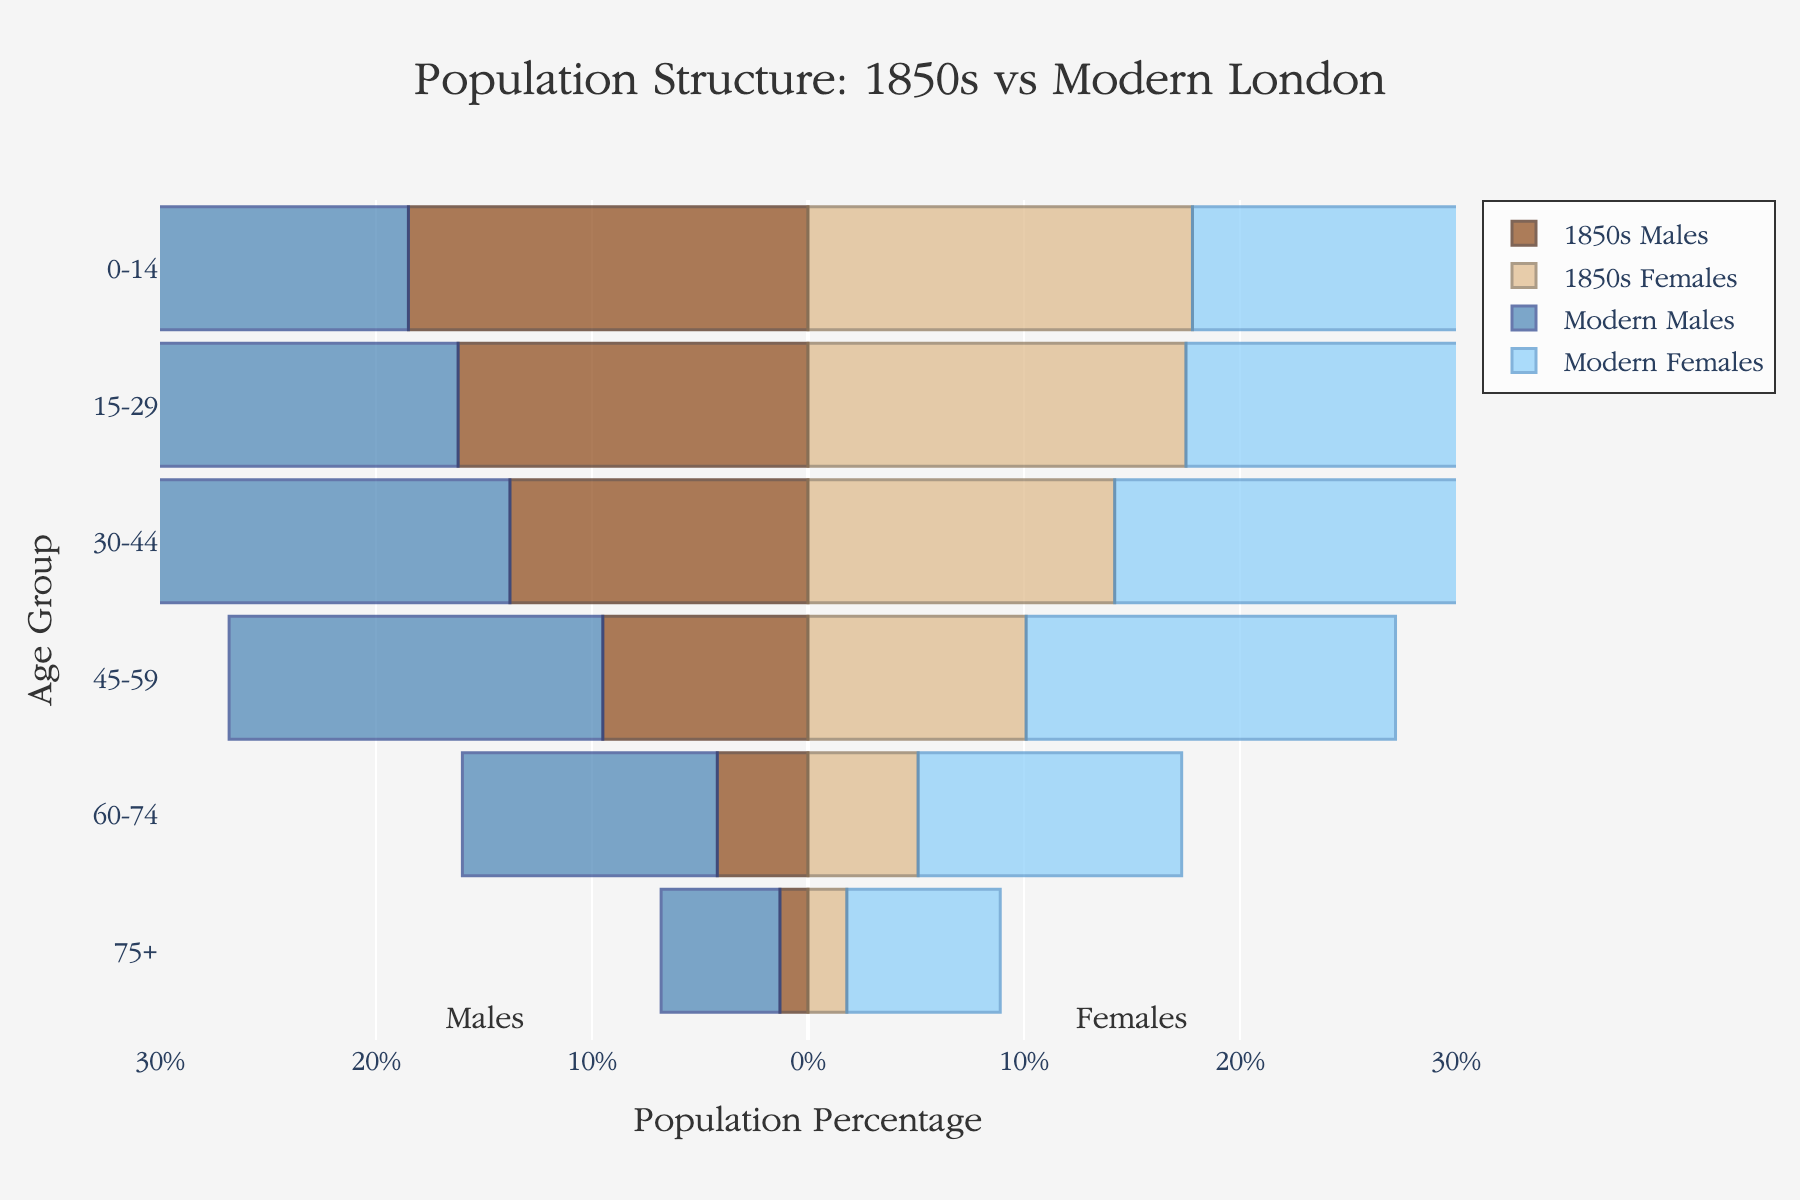What is the title of the figure? The title of the figure is displayed at the top center. It reads "Population Structure: 1850s vs Modern London."
Answer: Population Structure: 1850s vs Modern London What are the age groups listed on the y-axis? The y-axis lists the different age groups for both time periods being compared. They are: 0-14, 15-29, 30-44, 45-59, 60-74, and 75+.
Answer: 0-14, 15-29, 30-44, 45-59, 60-74, 75+ Which gender had a higher percentage of the population in the 15-29 age group in modern-day London? The blue bar representing Modern London Males and the light blue bar representing Modern London Females both fall within the 15-29 age group. The percentage for females is slightly higher.
Answer: Modern London Females In the 1850s, which age group had the highest percentage of females? By looking at the bars for the 1850s London Females, the highest percentage is in the 0-14 age group.
Answer: 0-14 In the age group 30-44, how does the percentage of modern London males compare with that of the 1850s London males? The percentage of modern London males (negative value) in the 30-44 age group is significantly higher than that of the 1850s London males. Specifically, it's 24.7% for modern London males versus 13.8% for the 1850s London males.
Answer: Higher for modern London males What is the ratio of the percentage of modern London females to modern London males in the 45-59 age group? The percentages for modern London females and males in the 45-59 age group are 17.1% and 17.3%, respectively. The ratio of females to males would be 17.1 / 17.3.
Answer: Approximately 0.99 How does the relative population structure of the elderly (75+) compare between the 1850s and modern-day London? The elderly population percentage is represented by the bars in the 75+ age group. For the 1850s, the percentages are 1.3% for males and 1.8% for females, whereas for modern-day London, they are 5.5% for males and 7.1% for females. Therefore, the elderly population is significantly higher in modern-day London for both genders.
Answer: Higher in modern-day London For both time periods, which gender generally has a higher percentage in the 60-74 age group? In the 60-74 age group, the bars for both time periods (1850s and modern-day) show a higher percentage of females compared to males.
Answer: Females What is the overall trend in the population structure from the 1850s to modern-day London across all age groups? Observing the bars from younger age groups (0-14) to older ones (75+), there is an evident increase in the percentage of the population in the middle to older age groups for modern-day London compared to the 1850s. This suggests a larger adult and elderly population in modern-day London.
Answer: Increase in adult and elderly population In which age group does modern-day London show the most significant increase in the male population compared to the 1850s? The increase can be observed more starkly in the age group 30-44, where modern-day London males have 24.7%, a significant rise compared to 13.8% for the 1850s London males.
Answer: 30-44 